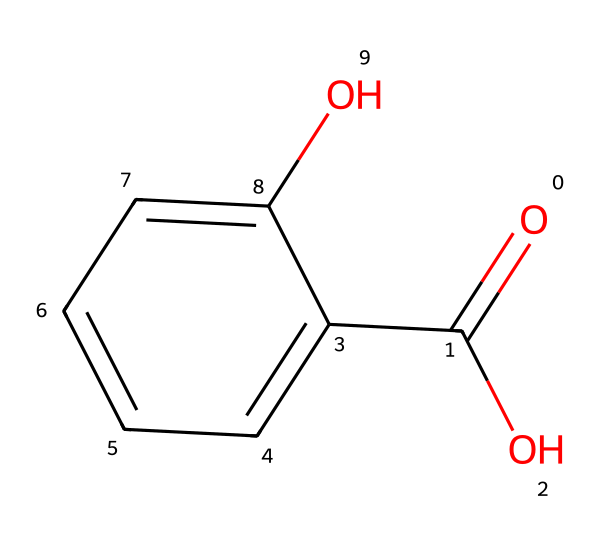What is the molecular formula of this compound? The molecular formula is determined by counting the number of each type of atom present in the chemical structure. In the given SMILES, we have 7 carbon (C) atoms, 6 hydrogen (H) atoms, and 3 oxygen (O) atoms. Thus, the formula is C7H6O3.
Answer: C7H6O3 How many hydroxyl (–OH) groups are present? By analyzing the structure, we can identify the hydroxyl groups, which are represented by the -OH functional group. The chemical structure contains one hydroxyl group directly attached to the aromatic ring and another bonded to the carboxylic acid. Therefore, there are two –OH groups.
Answer: 2 What functional groups are present in this chemical? The chemical structure reveals two main functional groups: a carboxylic acid (–COOH) group and a phenolic hydroxyl (–OH) group. The presence of the –COOH group can be seen from the carboxylate and the single –OH attached to the aromatic ring signifies phenolic characteristics.
Answer: carboxylic acid and phenolic hydroxyl How does salicylic acid function as an exfoliant? Salicylic acid, being a beta hydroxy acid (BHA), penetrates the pores and counters acne by promoting the shedding of dead skin cells and unclogging pores. This is facilitated by its ability to break down intercellular adhesions in the skin, leading to easier exfoliation and revealing healthier skin underneath.
Answer: promotes shedding of dead skin cells What is the total number of rings in the molecular structure? The structure contains one aromatic ring represented by the cyclic notation in the SMILES. An aromatic ring is characterized by alternating single and double bonds and is specifically present in this structure, which consists of six carbon atoms arranged in a ring. Therefore, the total number of rings is one.
Answer: 1 What type of chemical is salicylic acid classified as in skincare? Salicylic acid is classified as a beta hydroxy acid (BHA) in skincare, which categorizes it as a chemical exfoliant. This classification arises from its effective penetration into the skin and ability to facilitate exfoliation, making it beneficial in treating sun damage and acne.
Answer: beta hydroxy acid 